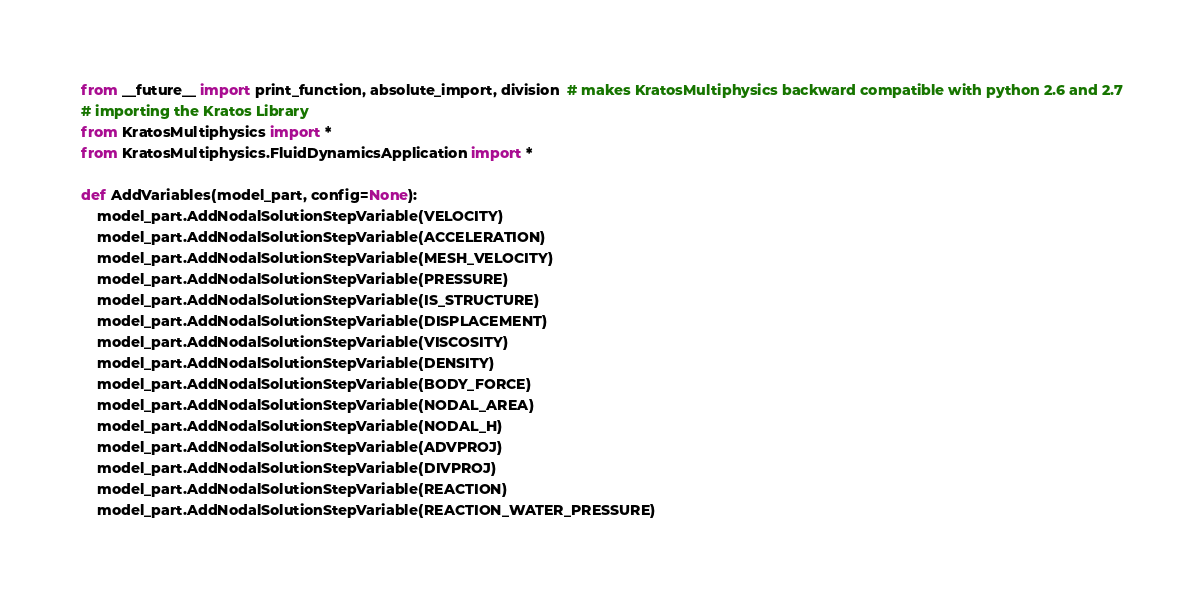<code> <loc_0><loc_0><loc_500><loc_500><_Python_>from __future__ import print_function, absolute_import, division  # makes KratosMultiphysics backward compatible with python 2.6 and 2.7
# importing the Kratos Library
from KratosMultiphysics import *
from KratosMultiphysics.FluidDynamicsApplication import *

def AddVariables(model_part, config=None):
    model_part.AddNodalSolutionStepVariable(VELOCITY)
    model_part.AddNodalSolutionStepVariable(ACCELERATION)
    model_part.AddNodalSolutionStepVariable(MESH_VELOCITY)
    model_part.AddNodalSolutionStepVariable(PRESSURE)
    model_part.AddNodalSolutionStepVariable(IS_STRUCTURE)
    model_part.AddNodalSolutionStepVariable(DISPLACEMENT)
    model_part.AddNodalSolutionStepVariable(VISCOSITY)
    model_part.AddNodalSolutionStepVariable(DENSITY)
    model_part.AddNodalSolutionStepVariable(BODY_FORCE)
    model_part.AddNodalSolutionStepVariable(NODAL_AREA)
    model_part.AddNodalSolutionStepVariable(NODAL_H)
    model_part.AddNodalSolutionStepVariable(ADVPROJ)
    model_part.AddNodalSolutionStepVariable(DIVPROJ)
    model_part.AddNodalSolutionStepVariable(REACTION)
    model_part.AddNodalSolutionStepVariable(REACTION_WATER_PRESSURE)</code> 